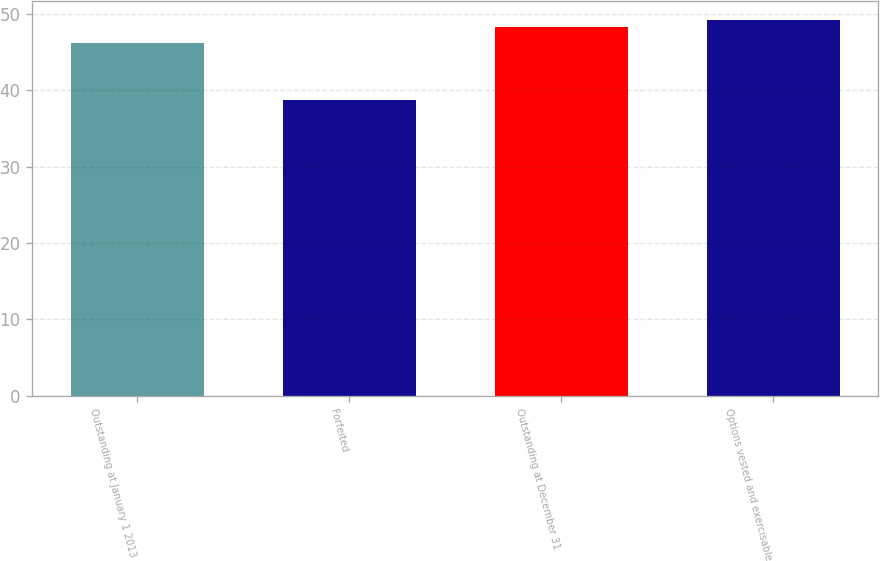Convert chart to OTSL. <chart><loc_0><loc_0><loc_500><loc_500><bar_chart><fcel>Outstanding at January 1 2013<fcel>Forfeited<fcel>Outstanding at December 31<fcel>Options vested and exercisable<nl><fcel>46.22<fcel>38.73<fcel>48.23<fcel>49.18<nl></chart> 